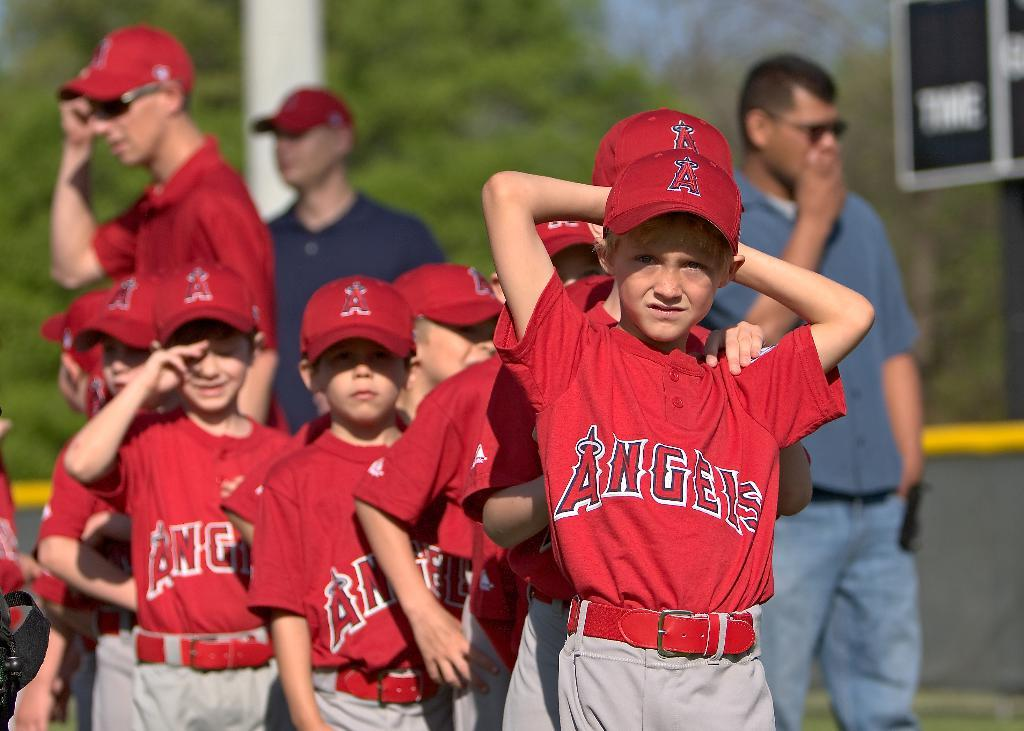<image>
Present a compact description of the photo's key features. little boys in red angels jersey in a line to play baseball 